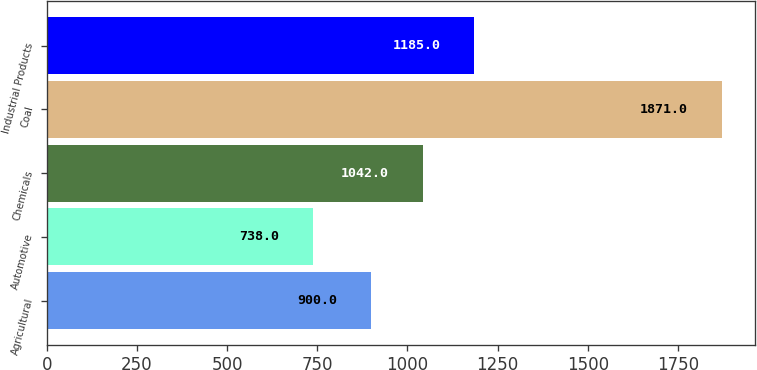Convert chart. <chart><loc_0><loc_0><loc_500><loc_500><bar_chart><fcel>Agricultural<fcel>Automotive<fcel>Chemicals<fcel>Coal<fcel>Industrial Products<nl><fcel>900<fcel>738<fcel>1042<fcel>1871<fcel>1185<nl></chart> 